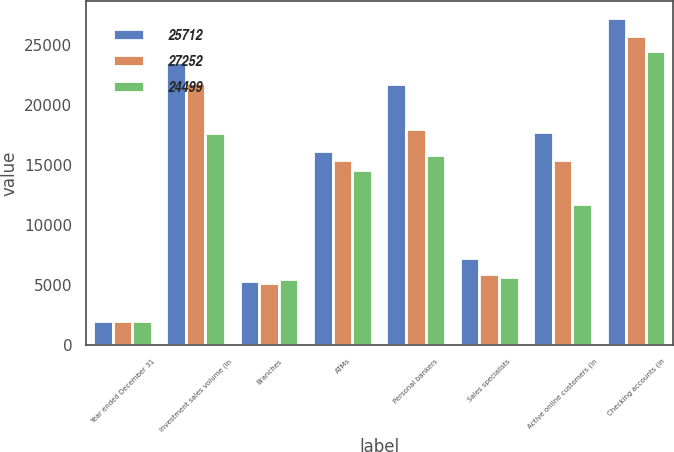Convert chart to OTSL. <chart><loc_0><loc_0><loc_500><loc_500><stacked_bar_chart><ecel><fcel>Year ended December 31<fcel>Investment sales volume (in<fcel>Branches<fcel>ATMs<fcel>Personal bankers<fcel>Sales specialists<fcel>Active online customers (in<fcel>Checking accounts (in<nl><fcel>25712<fcel>2010<fcel>23579<fcel>5268<fcel>16145<fcel>21715<fcel>7196<fcel>17744<fcel>27252<nl><fcel>27252<fcel>2009<fcel>21784<fcel>5154<fcel>15406<fcel>17991<fcel>5912<fcel>15424<fcel>25712<nl><fcel>24499<fcel>2008<fcel>17640<fcel>5474<fcel>14568<fcel>15825<fcel>5661<fcel>11710<fcel>24499<nl></chart> 